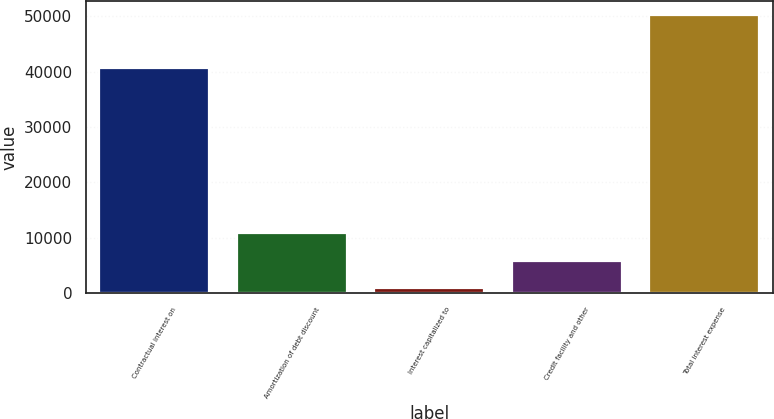Convert chart. <chart><loc_0><loc_0><loc_500><loc_500><bar_chart><fcel>Contractual interest on<fcel>Amortization of debt discount<fcel>Interest capitalized to<fcel>Credit facility and other<fcel>Total interest expense<nl><fcel>40625<fcel>10786.4<fcel>934<fcel>5860.2<fcel>50196<nl></chart> 